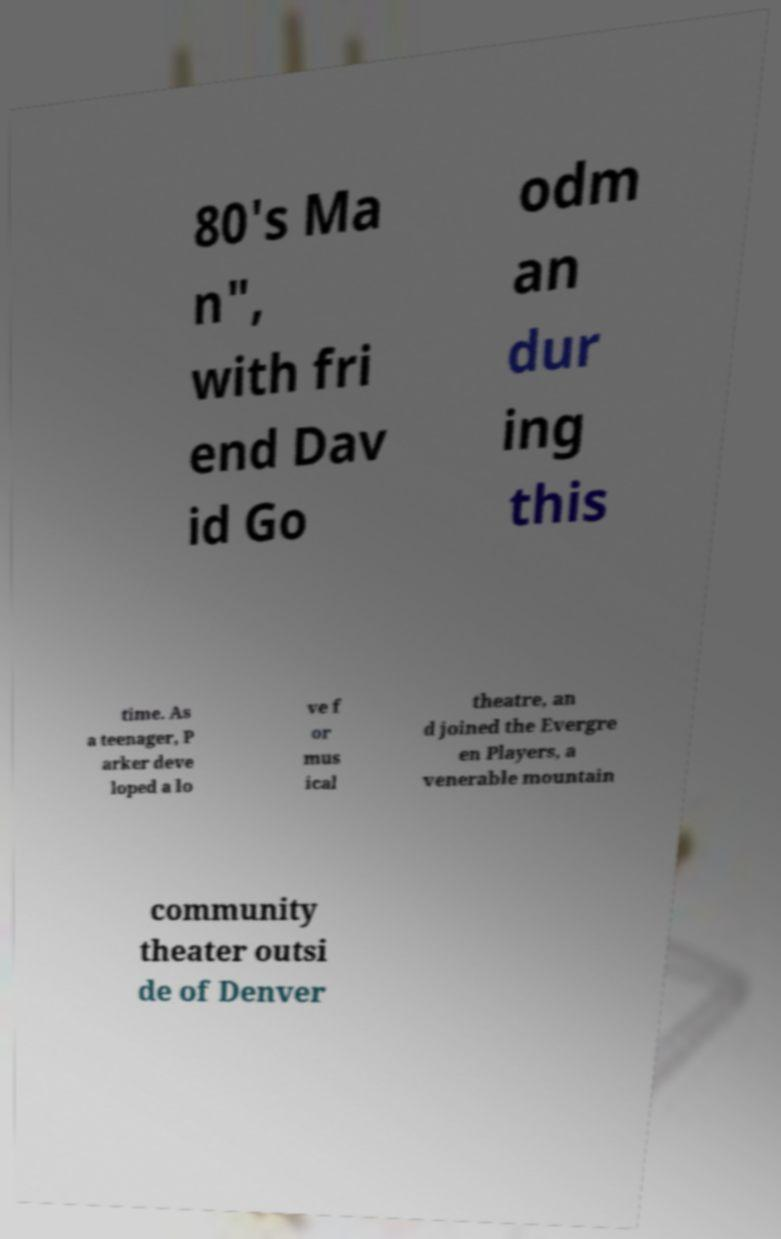For documentation purposes, I need the text within this image transcribed. Could you provide that? 80's Ma n", with fri end Dav id Go odm an dur ing this time. As a teenager, P arker deve loped a lo ve f or mus ical theatre, an d joined the Evergre en Players, a venerable mountain community theater outsi de of Denver 